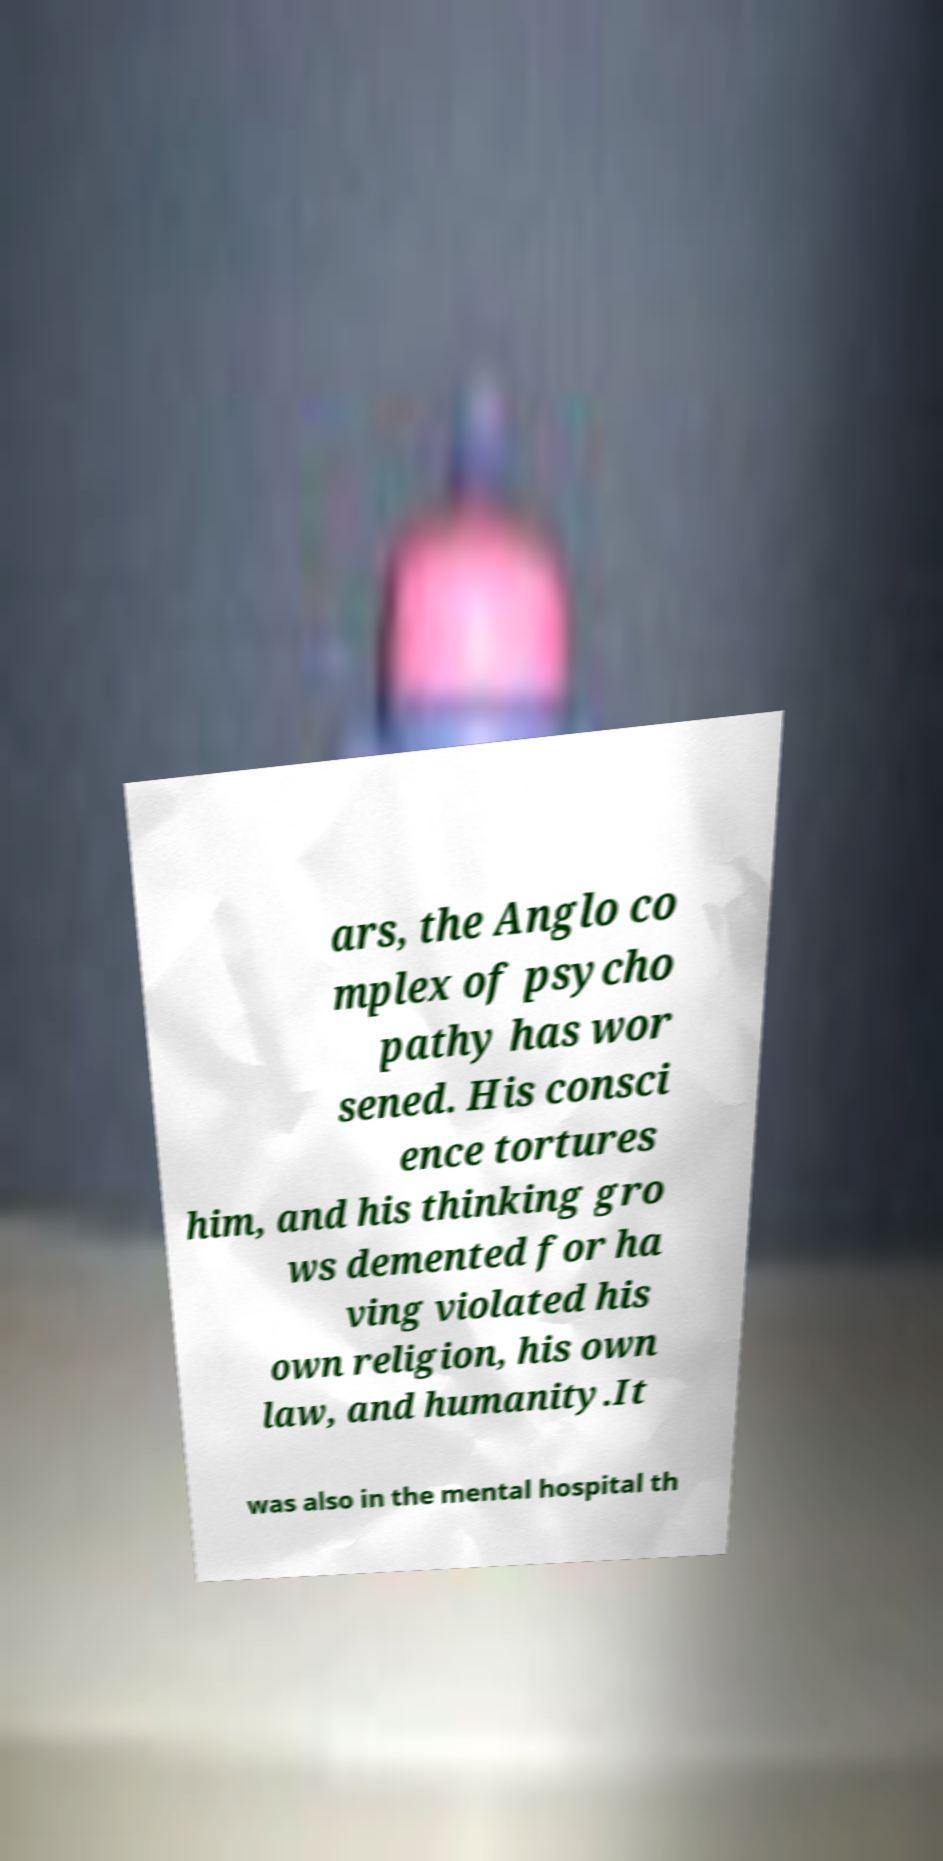There's text embedded in this image that I need extracted. Can you transcribe it verbatim? ars, the Anglo co mplex of psycho pathy has wor sened. His consci ence tortures him, and his thinking gro ws demented for ha ving violated his own religion, his own law, and humanity.It was also in the mental hospital th 